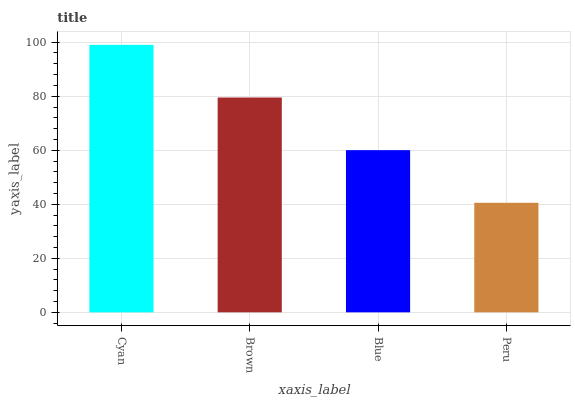Is Brown the minimum?
Answer yes or no. No. Is Brown the maximum?
Answer yes or no. No. Is Cyan greater than Brown?
Answer yes or no. Yes. Is Brown less than Cyan?
Answer yes or no. Yes. Is Brown greater than Cyan?
Answer yes or no. No. Is Cyan less than Brown?
Answer yes or no. No. Is Brown the high median?
Answer yes or no. Yes. Is Blue the low median?
Answer yes or no. Yes. Is Cyan the high median?
Answer yes or no. No. Is Brown the low median?
Answer yes or no. No. 